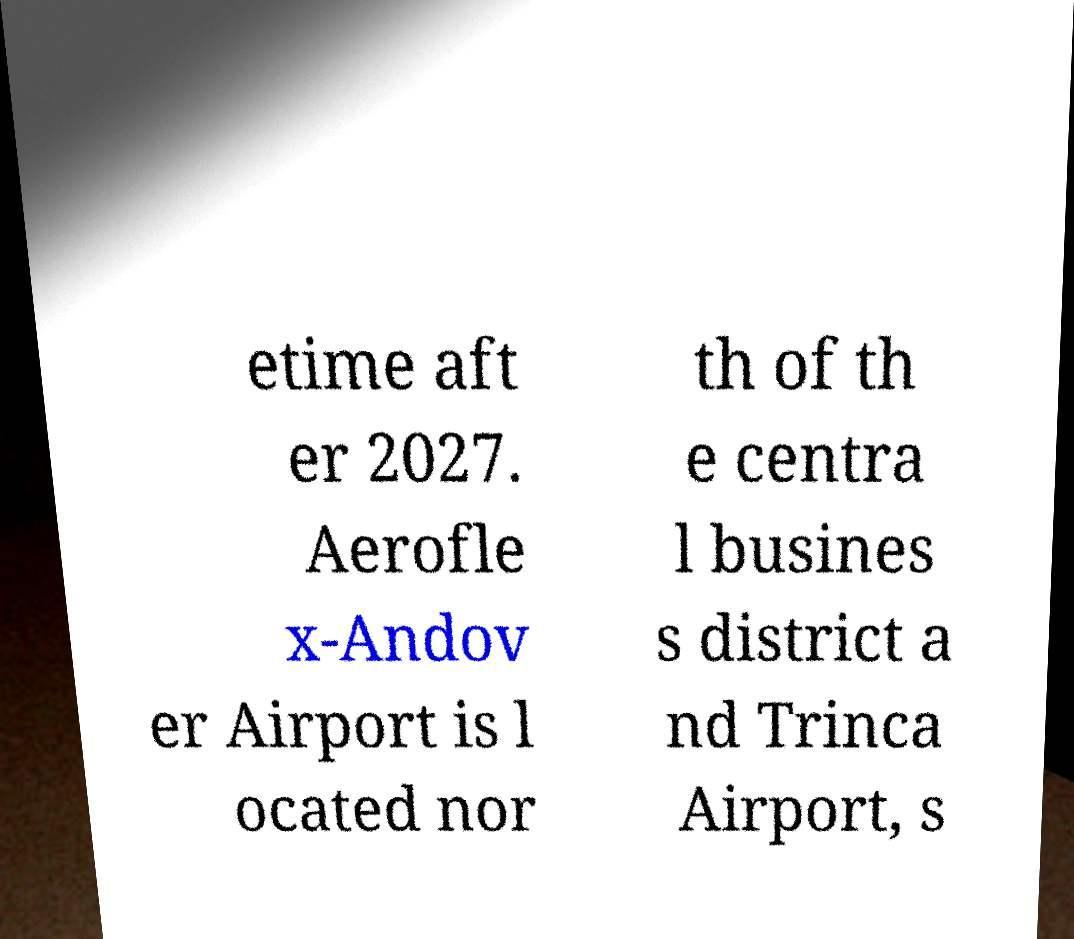Can you accurately transcribe the text from the provided image for me? etime aft er 2027. Aerofle x-Andov er Airport is l ocated nor th of th e centra l busines s district a nd Trinca Airport, s 